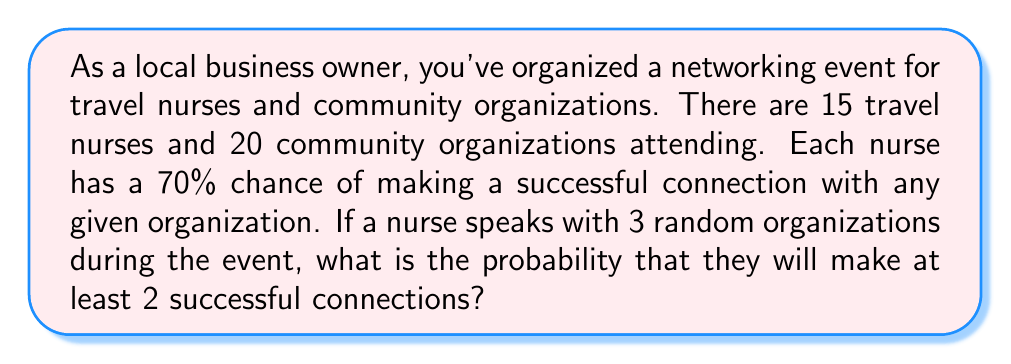Can you solve this math problem? Let's approach this step-by-step using the binomial probability distribution:

1) This scenario follows a binomial distribution because:
   - There are a fixed number of trials (3 organizations)
   - Each trial has two possible outcomes (success or failure)
   - The probability of success is the same for each trial (70%)
   - The trials are independent

2) We need to find P(X ≥ 2), where X is the number of successful connections.

3) We can calculate this as: P(X ≥ 2) = P(X = 2) + P(X = 3)

4) The probability mass function for a binomial distribution is:

   $$ P(X = k) = \binom{n}{k} p^k (1-p)^{n-k} $$

   Where:
   n = number of trials (3)
   k = number of successes
   p = probability of success (0.70)

5) Let's calculate P(X = 2):

   $$ P(X = 2) = \binom{3}{2} (0.70)^2 (1-0.70)^{3-2} $$
   $$ = 3 * 0.70^2 * 0.30^1 $$
   $$ = 3 * 0.49 * 0.30 $$
   $$ = 0.441 $$

6) Now, let's calculate P(X = 3):

   $$ P(X = 3) = \binom{3}{3} (0.70)^3 (1-0.70)^{3-3} $$
   $$ = 1 * 0.70^3 * 0.30^0 $$
   $$ = 0.343 $$

7) Finally, we sum these probabilities:

   P(X ≥ 2) = P(X = 2) + P(X = 3) = 0.441 + 0.343 = 0.784

Therefore, the probability of making at least 2 successful connections is 0.784 or 78.4%.
Answer: 0.784 